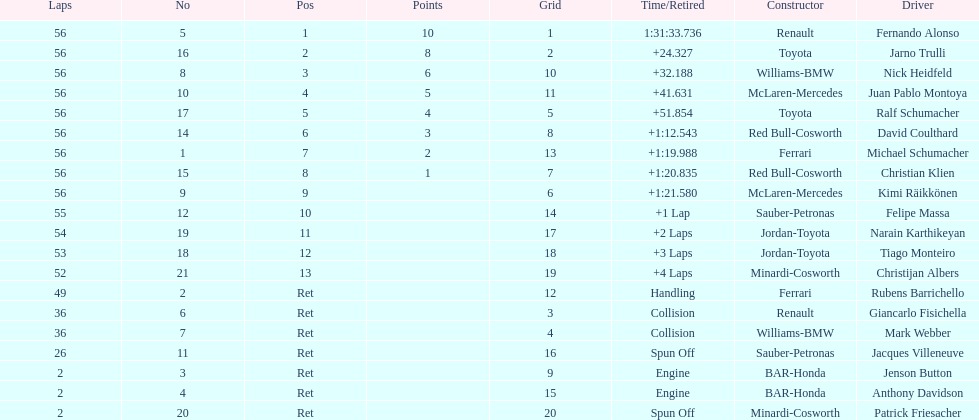How many germans finished in the top five? 2. 